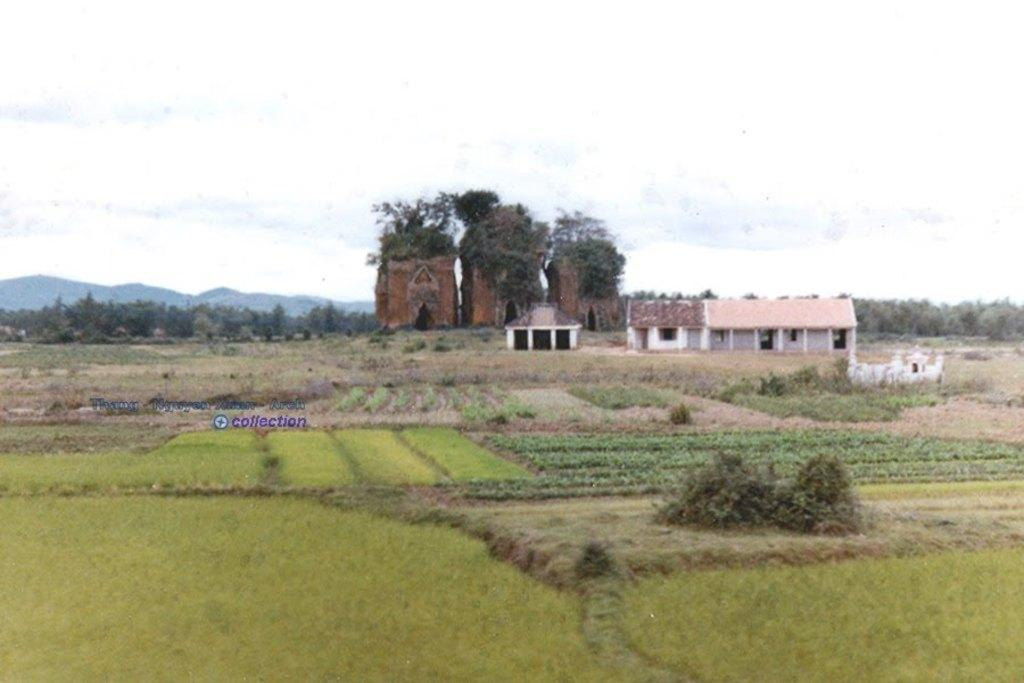What type of structures can be seen on the right side of the image? There are houses on the right side of the image. What is present at the bottom of the image? Crops are visible at the bottom of the image. What is the condition of the sky in the image? The sky is cloudy at the top of the image. Can you tell me how many firemen are taking care of the crops in the image? There are no firemen or any indication of crop care in the image. What color is the blood on the houses in the image? There is no blood present in the image. 